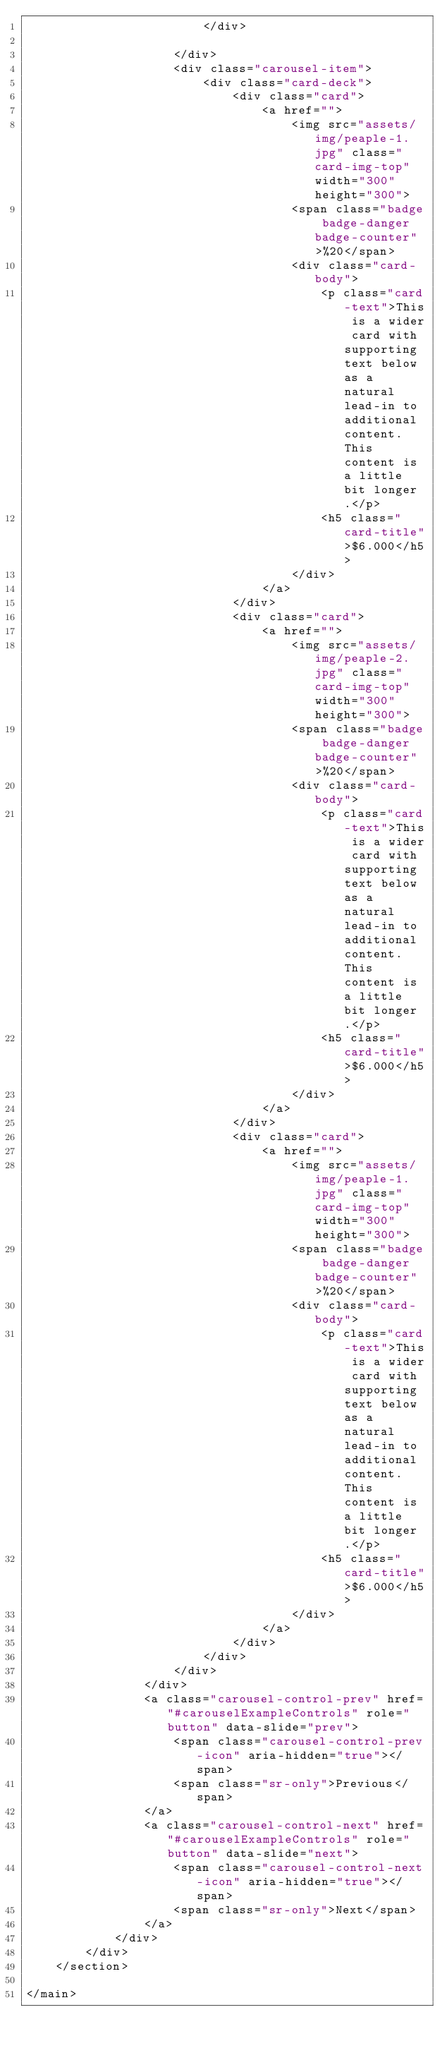<code> <loc_0><loc_0><loc_500><loc_500><_PHP_>                        </div>

                    </div>
                    <div class="carousel-item">
                        <div class="card-deck">
                            <div class="card">
                                <a href="">
                                    <img src="assets/img/peaple-1.jpg" class="card-img-top" width="300" height="300">
                                    <span class="badge badge-danger badge-counter">%20</span>
                                    <div class="card-body">
                                        <p class="card-text">This is a wider card with supporting text below as a natural lead-in to additional content. This content is a little bit longer.</p>
                                        <h5 class="card-title">$6.000</h5>
                                    </div>
                                </a>
                            </div>
                            <div class="card">
                                <a href="">
                                    <img src="assets/img/peaple-2.jpg" class="card-img-top" width="300" height="300">
                                    <span class="badge badge-danger badge-counter">%20</span>
                                    <div class="card-body">
                                        <p class="card-text">This is a wider card with supporting text below as a natural lead-in to additional content. This content is a little bit longer.</p>
                                        <h5 class="card-title">$6.000</h5>
                                    </div>
                                </a>
                            </div>
                            <div class="card">
                                <a href="">
                                    <img src="assets/img/peaple-1.jpg" class="card-img-top" width="300" height="300">
                                    <span class="badge badge-danger badge-counter">%20</span>
                                    <div class="card-body">
                                        <p class="card-text">This is a wider card with supporting text below as a natural lead-in to additional content. This content is a little bit longer.</p>
                                        <h5 class="card-title">$6.000</h5>
                                    </div>
                                </a>
                            </div>
                        </div>
                    </div>
                </div>
                <a class="carousel-control-prev" href="#carouselExampleControls" role="button" data-slide="prev">
                    <span class="carousel-control-prev-icon" aria-hidden="true"></span>
                    <span class="sr-only">Previous</span>
                </a>
                <a class="carousel-control-next" href="#carouselExampleControls" role="button" data-slide="next">
                    <span class="carousel-control-next-icon" aria-hidden="true"></span>
                    <span class="sr-only">Next</span>
                </a>
            </div>
        </div>
    </section>

</main></code> 